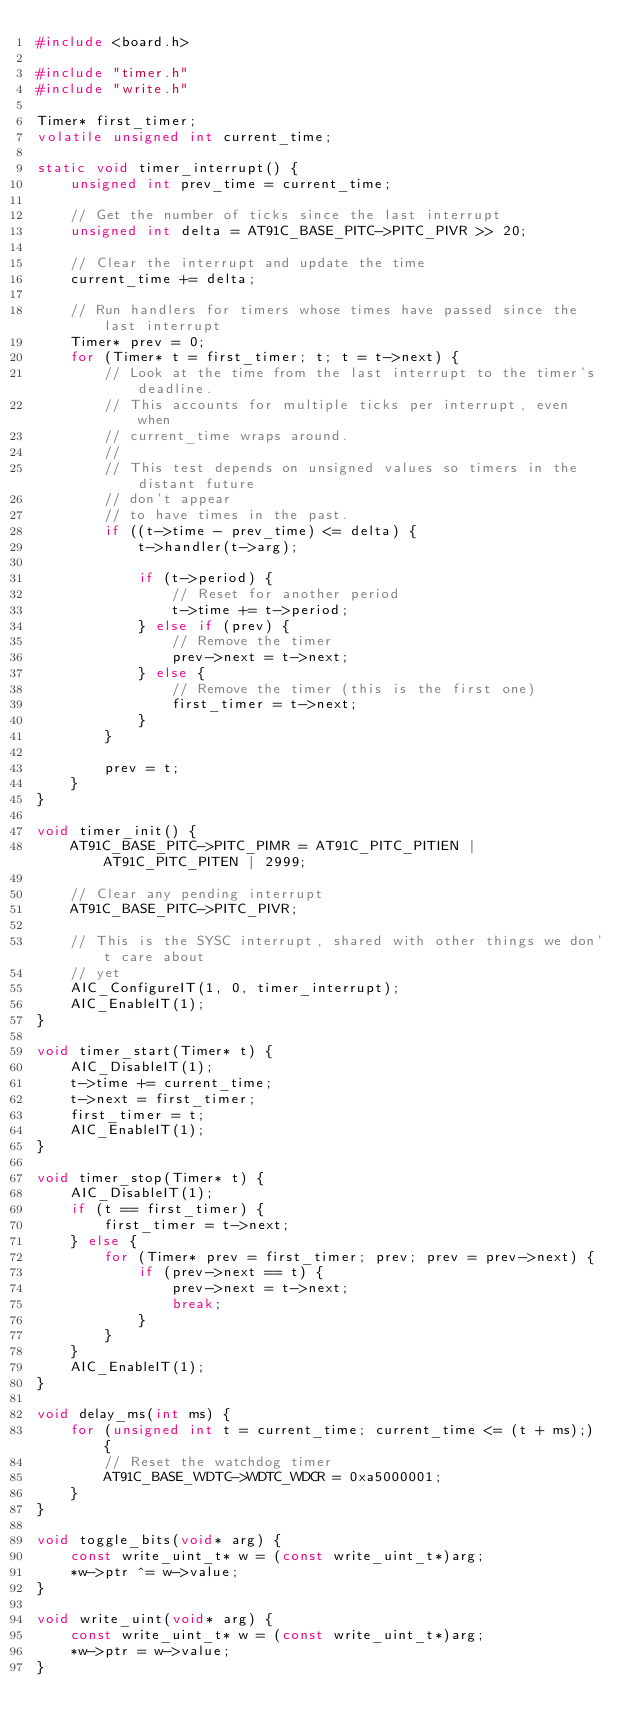Convert code to text. <code><loc_0><loc_0><loc_500><loc_500><_C_>#include <board.h>

#include "timer.h"
#include "write.h"

Timer* first_timer;
volatile unsigned int current_time;

static void timer_interrupt() {
    unsigned int prev_time = current_time;

    // Get the number of ticks since the last interrupt
    unsigned int delta = AT91C_BASE_PITC->PITC_PIVR >> 20;

    // Clear the interrupt and update the time
    current_time += delta;

    // Run handlers for timers whose times have passed since the last interrupt
    Timer* prev = 0;
    for (Timer* t = first_timer; t; t = t->next) {
        // Look at the time from the last interrupt to the timer's deadline.
        // This accounts for multiple ticks per interrupt, even when
        // current_time wraps around.
        //
        // This test depends on unsigned values so timers in the distant future
        // don't appear
        // to have times in the past.
        if ((t->time - prev_time) <= delta) {
            t->handler(t->arg);

            if (t->period) {
                // Reset for another period
                t->time += t->period;
            } else if (prev) {
                // Remove the timer
                prev->next = t->next;
            } else {
                // Remove the timer (this is the first one)
                first_timer = t->next;
            }
        }

        prev = t;
    }
}

void timer_init() {
    AT91C_BASE_PITC->PITC_PIMR = AT91C_PITC_PITIEN | AT91C_PITC_PITEN | 2999;

    // Clear any pending interrupt
    AT91C_BASE_PITC->PITC_PIVR;

    // This is the SYSC interrupt, shared with other things we don't care about
    // yet
    AIC_ConfigureIT(1, 0, timer_interrupt);
    AIC_EnableIT(1);
}

void timer_start(Timer* t) {
    AIC_DisableIT(1);
    t->time += current_time;
    t->next = first_timer;
    first_timer = t;
    AIC_EnableIT(1);
}

void timer_stop(Timer* t) {
    AIC_DisableIT(1);
    if (t == first_timer) {
        first_timer = t->next;
    } else {
        for (Timer* prev = first_timer; prev; prev = prev->next) {
            if (prev->next == t) {
                prev->next = t->next;
                break;
            }
        }
    }
    AIC_EnableIT(1);
}

void delay_ms(int ms) {
    for (unsigned int t = current_time; current_time <= (t + ms);) {
        // Reset the watchdog timer
        AT91C_BASE_WDTC->WDTC_WDCR = 0xa5000001;
    }
}

void toggle_bits(void* arg) {
    const write_uint_t* w = (const write_uint_t*)arg;
    *w->ptr ^= w->value;
}

void write_uint(void* arg) {
    const write_uint_t* w = (const write_uint_t*)arg;
    *w->ptr = w->value;
}
</code> 